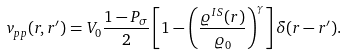<formula> <loc_0><loc_0><loc_500><loc_500>v _ { p p } ( r , r ^ { \prime } ) = V _ { 0 } \frac { 1 - P _ { \sigma } } { 2 } \left [ 1 - \left ( \frac { \varrho ^ { I S } ( r ) } { \varrho _ { 0 } } \right ) ^ { \gamma } \right ] \delta ( r - r ^ { \prime } ) .</formula> 